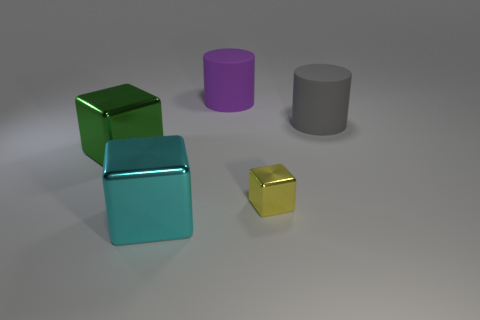How does the lighting in the image affect the appearance of the objects? The lighting in the image casts diffuse shadows and provides a soft glow on the objects, highlighting their colors and glossy surfaces. It creates a calm atmosphere and brings out the texture and shape of each object, allowing us to perceive their material qualities. 